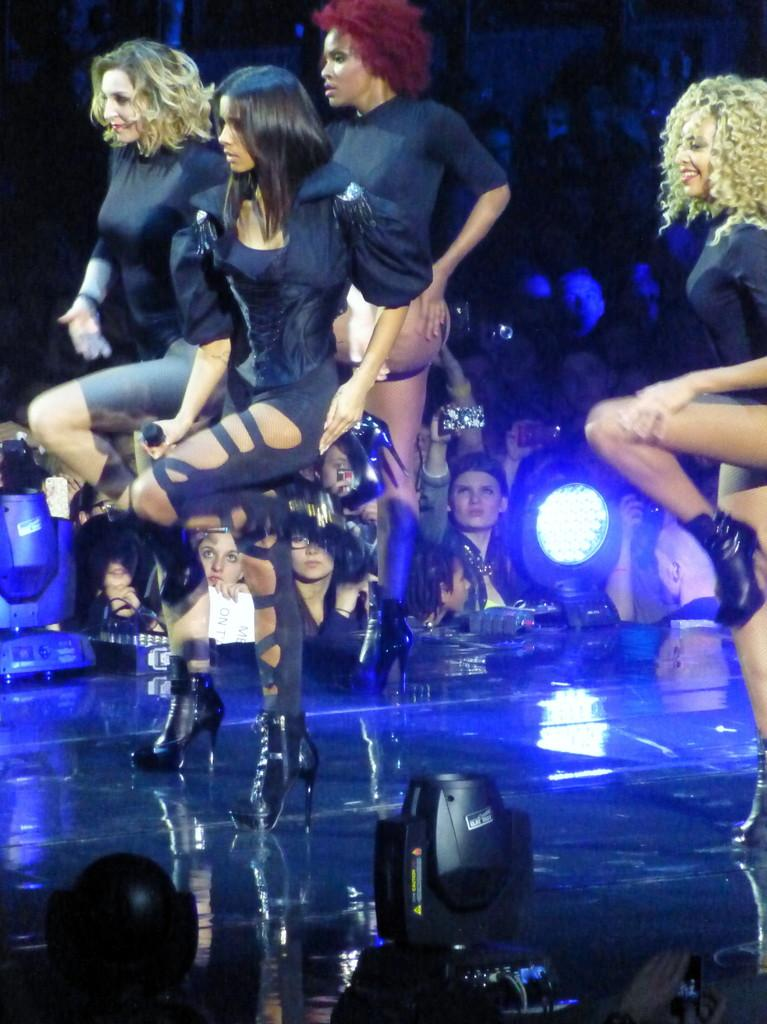What are the ladies in the image doing? The ladies are standing on the stage. Can you describe the setting of the image? There are people in the background of the image. What can be seen in the image that provides illumination? There are lights visible in the image. What type of vessel is being used by the family in the image? There is no family or vessel present in the image. What type of suit is the man wearing in the image? There is no man or suit present in the image. 